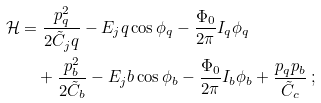<formula> <loc_0><loc_0><loc_500><loc_500>\mathcal { H } & = \frac { p _ { q } ^ { 2 } } { 2 \tilde { C } _ { j } q } - E _ { j } q \cos \phi _ { q } - \frac { \Phi _ { 0 } } { 2 \pi } I _ { q } \phi _ { q } \\ & \quad + \frac { p _ { b } ^ { 2 } } { 2 \tilde { C } _ { b } } - E _ { j } b \cos \phi _ { b } - \frac { \Phi _ { 0 } } { 2 \pi } I _ { b } \phi _ { b } + \frac { p _ { q } p _ { b } } { \tilde { C } _ { c } } \, ;</formula> 